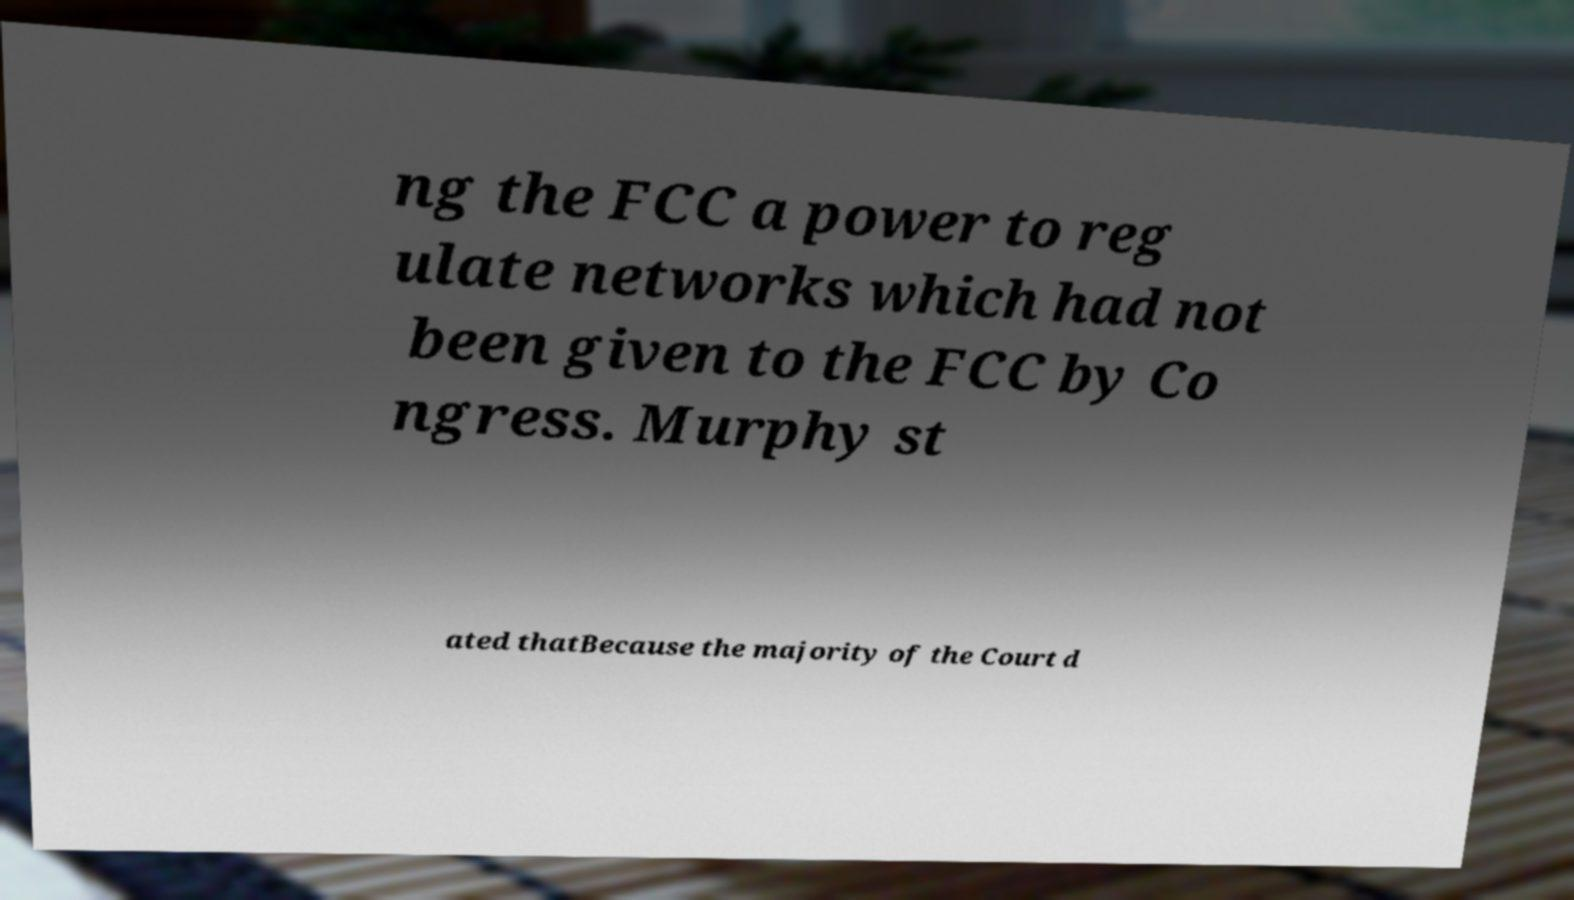For documentation purposes, I need the text within this image transcribed. Could you provide that? ng the FCC a power to reg ulate networks which had not been given to the FCC by Co ngress. Murphy st ated thatBecause the majority of the Court d 